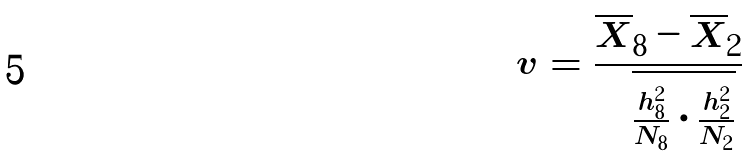Convert formula to latex. <formula><loc_0><loc_0><loc_500><loc_500>v = \frac { \overline { X } _ { 8 } - \overline { X } _ { 2 } } { \sqrt { \frac { h _ { 8 } ^ { 2 } } { N _ { 8 } } \cdot \frac { h _ { 2 } ^ { 2 } } { N _ { 2 } } } }</formula> 